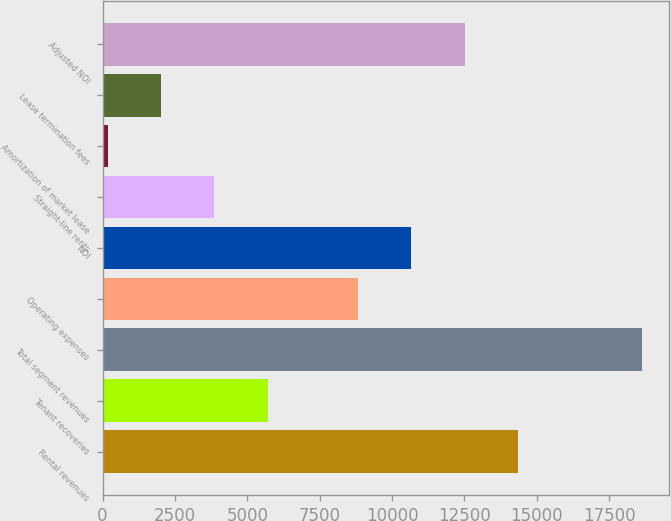Convert chart to OTSL. <chart><loc_0><loc_0><loc_500><loc_500><bar_chart><fcel>Rental revenues<fcel>Tenant recoveries<fcel>Total segment revenues<fcel>Operating expenses<fcel>NOI<fcel>Straight-line rents<fcel>Amortization of market lease<fcel>Lease termination fees<fcel>Adjusted NOI<nl><fcel>14356.8<fcel>5709.8<fcel>18622<fcel>8823<fcel>10667.6<fcel>3865.2<fcel>176<fcel>2020.6<fcel>12512.2<nl></chart> 